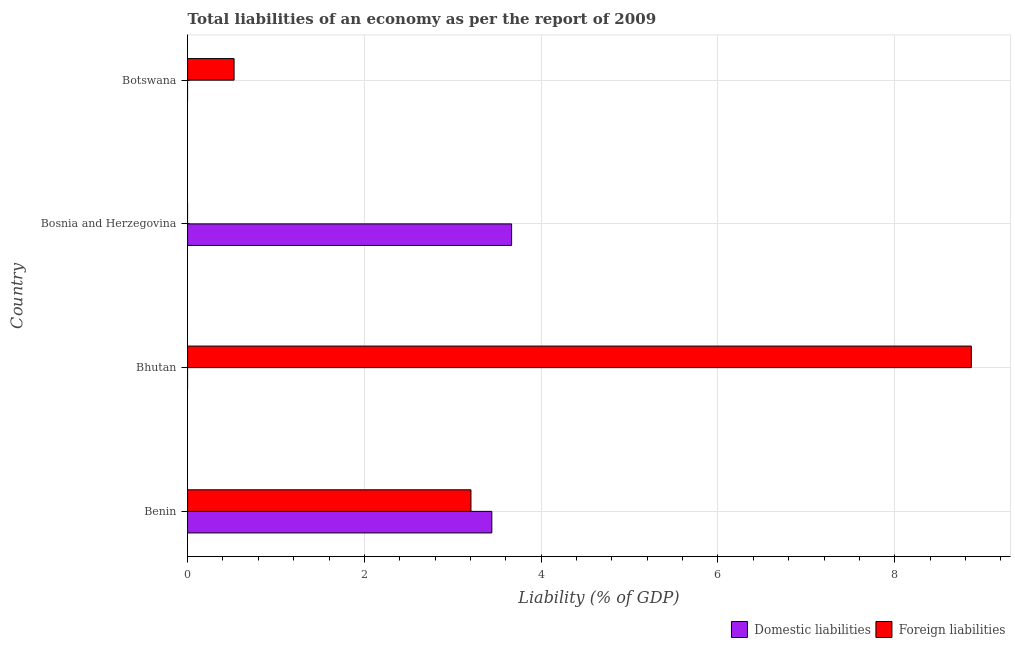How many different coloured bars are there?
Your answer should be compact. 2. How many bars are there on the 2nd tick from the bottom?
Make the answer very short. 1. What is the label of the 1st group of bars from the top?
Offer a very short reply. Botswana. In how many cases, is the number of bars for a given country not equal to the number of legend labels?
Your response must be concise. 3. Across all countries, what is the maximum incurrence of foreign liabilities?
Provide a short and direct response. 8.87. In which country was the incurrence of domestic liabilities maximum?
Offer a terse response. Bosnia and Herzegovina. What is the total incurrence of domestic liabilities in the graph?
Provide a short and direct response. 7.11. What is the difference between the incurrence of foreign liabilities in Benin and that in Bhutan?
Offer a terse response. -5.66. What is the average incurrence of foreign liabilities per country?
Your response must be concise. 3.15. What is the difference between the incurrence of foreign liabilities and incurrence of domestic liabilities in Benin?
Ensure brevity in your answer.  -0.24. In how many countries, is the incurrence of domestic liabilities greater than 1.6 %?
Offer a very short reply. 2. What is the difference between the highest and the second highest incurrence of foreign liabilities?
Give a very brief answer. 5.66. What is the difference between the highest and the lowest incurrence of foreign liabilities?
Your answer should be very brief. 8.87. In how many countries, is the incurrence of domestic liabilities greater than the average incurrence of domestic liabilities taken over all countries?
Ensure brevity in your answer.  2. Is the sum of the incurrence of foreign liabilities in Bhutan and Botswana greater than the maximum incurrence of domestic liabilities across all countries?
Make the answer very short. Yes. How many bars are there?
Ensure brevity in your answer.  5. Are all the bars in the graph horizontal?
Your answer should be very brief. Yes. Are the values on the major ticks of X-axis written in scientific E-notation?
Keep it short and to the point. No. Does the graph contain grids?
Make the answer very short. Yes. Where does the legend appear in the graph?
Keep it short and to the point. Bottom right. How many legend labels are there?
Your answer should be very brief. 2. How are the legend labels stacked?
Your response must be concise. Horizontal. What is the title of the graph?
Make the answer very short. Total liabilities of an economy as per the report of 2009. Does "Investment" appear as one of the legend labels in the graph?
Provide a short and direct response. No. What is the label or title of the X-axis?
Give a very brief answer. Liability (% of GDP). What is the label or title of the Y-axis?
Offer a terse response. Country. What is the Liability (% of GDP) of Domestic liabilities in Benin?
Offer a very short reply. 3.44. What is the Liability (% of GDP) of Foreign liabilities in Benin?
Make the answer very short. 3.21. What is the Liability (% of GDP) of Foreign liabilities in Bhutan?
Offer a very short reply. 8.87. What is the Liability (% of GDP) in Domestic liabilities in Bosnia and Herzegovina?
Your answer should be very brief. 3.67. What is the Liability (% of GDP) of Foreign liabilities in Botswana?
Provide a succinct answer. 0.53. Across all countries, what is the maximum Liability (% of GDP) in Domestic liabilities?
Offer a terse response. 3.67. Across all countries, what is the maximum Liability (% of GDP) of Foreign liabilities?
Make the answer very short. 8.87. Across all countries, what is the minimum Liability (% of GDP) of Foreign liabilities?
Your answer should be compact. 0. What is the total Liability (% of GDP) of Domestic liabilities in the graph?
Provide a succinct answer. 7.11. What is the total Liability (% of GDP) in Foreign liabilities in the graph?
Your answer should be very brief. 12.6. What is the difference between the Liability (% of GDP) in Foreign liabilities in Benin and that in Bhutan?
Your answer should be compact. -5.66. What is the difference between the Liability (% of GDP) of Domestic liabilities in Benin and that in Bosnia and Herzegovina?
Offer a terse response. -0.22. What is the difference between the Liability (% of GDP) in Foreign liabilities in Benin and that in Botswana?
Offer a terse response. 2.68. What is the difference between the Liability (% of GDP) of Foreign liabilities in Bhutan and that in Botswana?
Your answer should be very brief. 8.34. What is the difference between the Liability (% of GDP) in Domestic liabilities in Benin and the Liability (% of GDP) in Foreign liabilities in Bhutan?
Offer a terse response. -5.42. What is the difference between the Liability (% of GDP) in Domestic liabilities in Benin and the Liability (% of GDP) in Foreign liabilities in Botswana?
Your answer should be compact. 2.92. What is the difference between the Liability (% of GDP) in Domestic liabilities in Bosnia and Herzegovina and the Liability (% of GDP) in Foreign liabilities in Botswana?
Your answer should be very brief. 3.14. What is the average Liability (% of GDP) of Domestic liabilities per country?
Provide a short and direct response. 1.78. What is the average Liability (% of GDP) in Foreign liabilities per country?
Your answer should be very brief. 3.15. What is the difference between the Liability (% of GDP) in Domestic liabilities and Liability (% of GDP) in Foreign liabilities in Benin?
Offer a very short reply. 0.24. What is the ratio of the Liability (% of GDP) of Foreign liabilities in Benin to that in Bhutan?
Offer a very short reply. 0.36. What is the ratio of the Liability (% of GDP) of Domestic liabilities in Benin to that in Bosnia and Herzegovina?
Give a very brief answer. 0.94. What is the ratio of the Liability (% of GDP) in Foreign liabilities in Benin to that in Botswana?
Provide a succinct answer. 6.1. What is the ratio of the Liability (% of GDP) in Foreign liabilities in Bhutan to that in Botswana?
Your answer should be compact. 16.86. What is the difference between the highest and the second highest Liability (% of GDP) of Foreign liabilities?
Offer a very short reply. 5.66. What is the difference between the highest and the lowest Liability (% of GDP) in Domestic liabilities?
Offer a terse response. 3.67. What is the difference between the highest and the lowest Liability (% of GDP) in Foreign liabilities?
Provide a succinct answer. 8.87. 